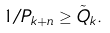Convert formula to latex. <formula><loc_0><loc_0><loc_500><loc_500>1 / P _ { k + n } \geq \tilde { Q } _ { k } .</formula> 